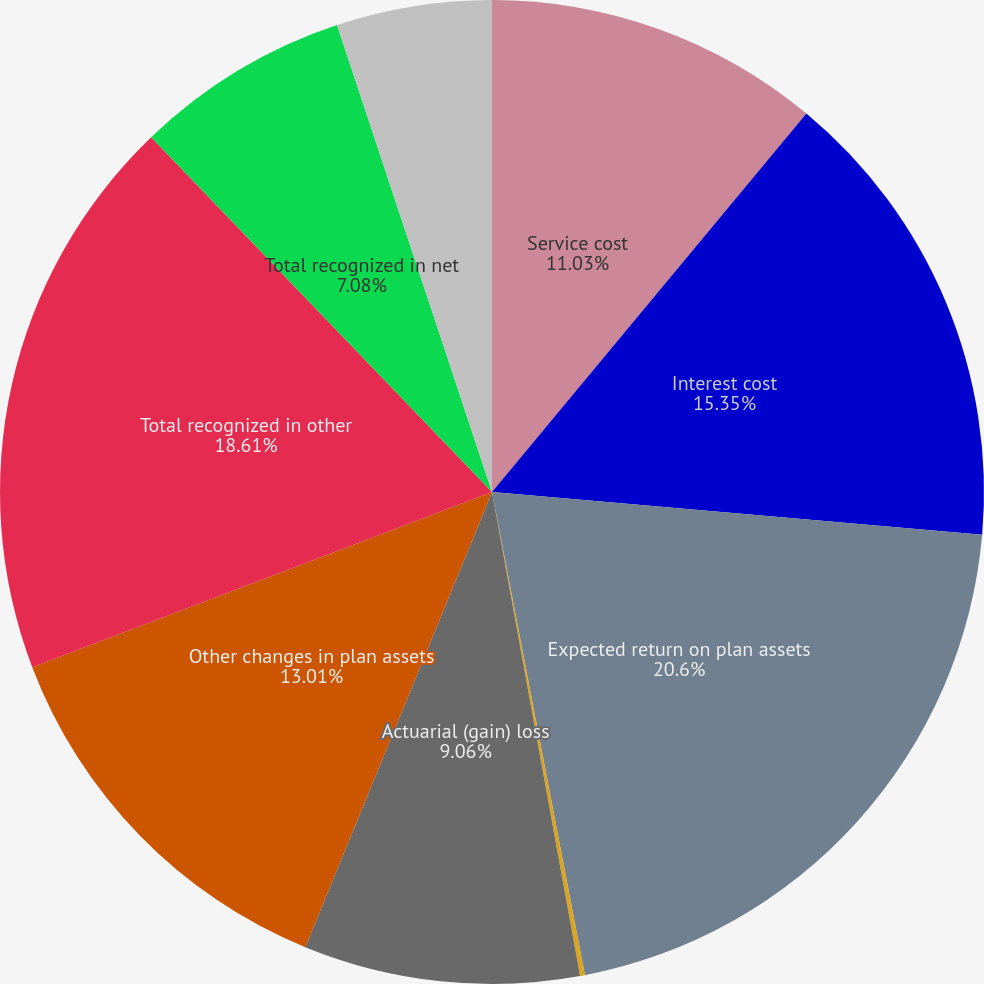<chart> <loc_0><loc_0><loc_500><loc_500><pie_chart><fcel>Service cost<fcel>Interest cost<fcel>Expected return on plan assets<fcel>Prior service cost (credit)<fcel>Actuarial (gain) loss<fcel>Other changes in plan assets<fcel>Total recognized in other<fcel>Total recognized in net<fcel>Net periodic other<nl><fcel>11.03%<fcel>15.35%<fcel>20.59%<fcel>0.16%<fcel>9.06%<fcel>13.01%<fcel>18.61%<fcel>7.08%<fcel>5.1%<nl></chart> 